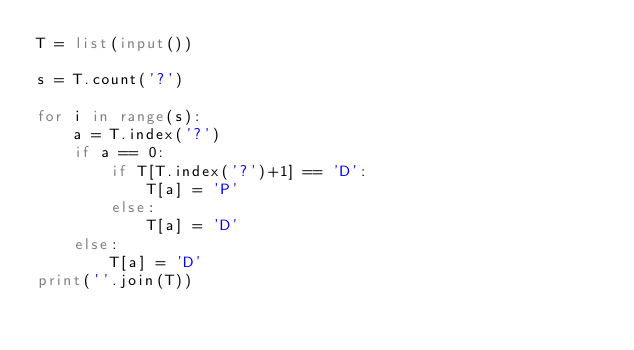Convert code to text. <code><loc_0><loc_0><loc_500><loc_500><_Python_>T = list(input())

s = T.count('?')

for i in range(s):
    a = T.index('?')
    if a == 0:
        if T[T.index('?')+1] == 'D':
            T[a] = 'P'
        else:
            T[a] = 'D'
    else:
        T[a] = 'D'
print(''.join(T))</code> 